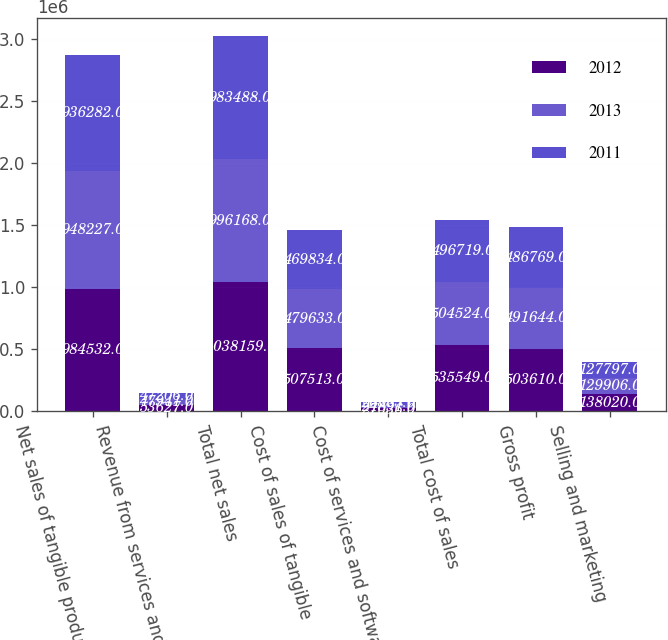Convert chart to OTSL. <chart><loc_0><loc_0><loc_500><loc_500><stacked_bar_chart><ecel><fcel>Net sales of tangible products<fcel>Revenue from services and<fcel>Total net sales<fcel>Cost of sales of tangible<fcel>Cost of services and software<fcel>Total cost of sales<fcel>Gross profit<fcel>Selling and marketing<nl><fcel>2012<fcel>984532<fcel>53627<fcel>1.03816e+06<fcel>507513<fcel>27036<fcel>535549<fcel>503610<fcel>138020<nl><fcel>2013<fcel>948227<fcel>47941<fcel>996168<fcel>479633<fcel>24891<fcel>504524<fcel>491644<fcel>129906<nl><fcel>2011<fcel>936282<fcel>47206<fcel>983488<fcel>469834<fcel>26885<fcel>496719<fcel>486769<fcel>127797<nl></chart> 